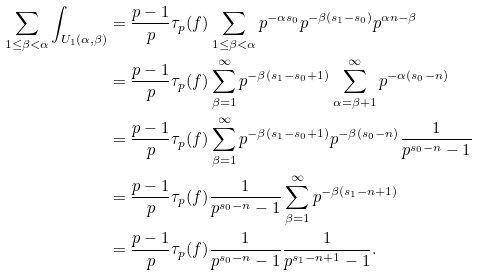Convert formula to latex. <formula><loc_0><loc_0><loc_500><loc_500>\sum _ { 1 \leq \beta < \alpha } \int _ { U _ { 1 } ( \alpha , \beta ) } & = \frac { p - 1 } p \tau _ { p } ( f ) \sum _ { 1 \leq \beta < \alpha } p ^ { - \alpha s _ { 0 } } p ^ { - \beta ( s _ { 1 } - s _ { 0 } ) } p ^ { \alpha n - \beta } \\ & = \frac { p - 1 } p \tau _ { p } ( f ) \sum _ { \beta = 1 } ^ { \infty } p ^ { - \beta ( s _ { 1 } - s _ { 0 } + 1 ) } \sum _ { \alpha = \beta + 1 } ^ { \infty } p ^ { - \alpha ( s _ { 0 } - n ) } \\ & = \frac { p - 1 } p \tau _ { p } ( f ) \sum _ { \beta = 1 } ^ { \infty } p ^ { - \beta ( s _ { 1 } - s _ { 0 } + 1 ) } p ^ { - \beta ( s _ { 0 } - n ) } \frac { 1 } { p ^ { s _ { 0 } - n } - 1 } \\ & = \frac { p - 1 } p \tau _ { p } ( f ) \frac { 1 } { p ^ { s _ { 0 } - n } - 1 } \sum _ { \beta = 1 } ^ { \infty } p ^ { - \beta ( s _ { 1 } - n + 1 ) } \\ & = \frac { p - 1 } p \tau _ { p } ( f ) \frac { 1 } { p ^ { s _ { 0 } - n } - 1 } \frac { 1 } { p ^ { s _ { 1 } - n + 1 } - 1 } .</formula> 